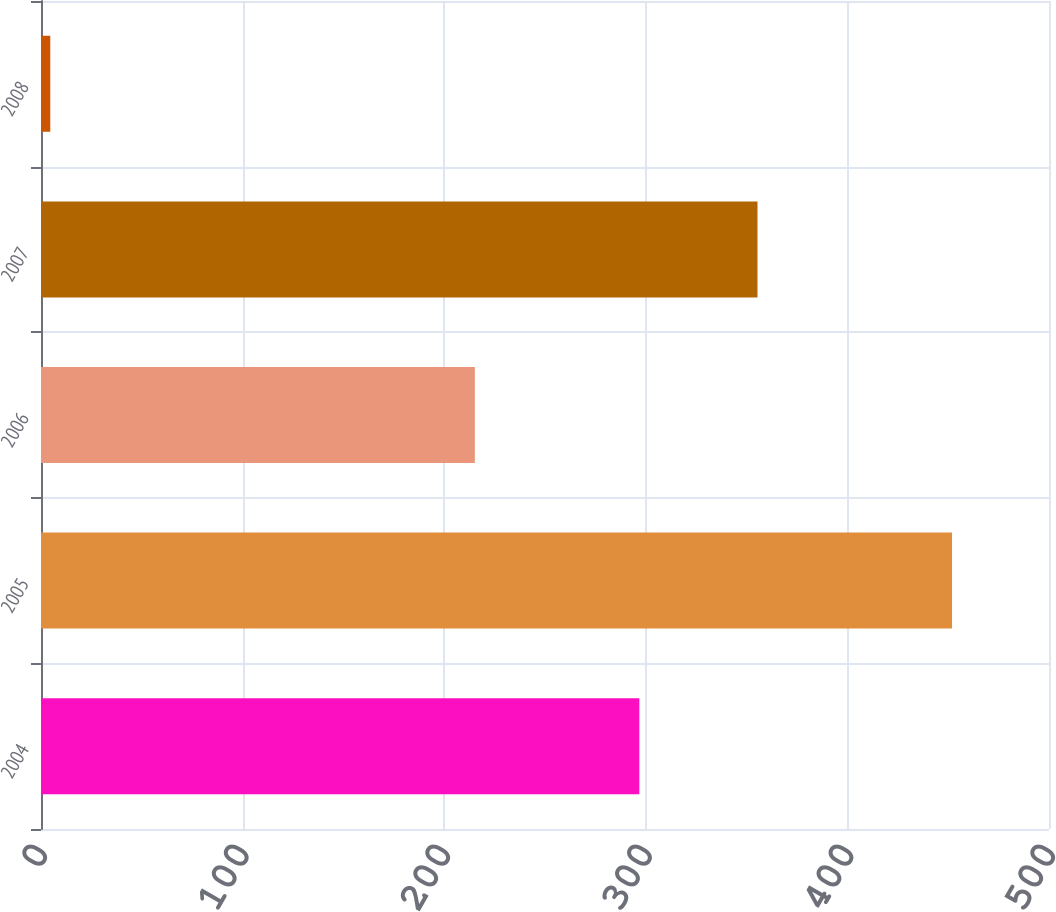Convert chart to OTSL. <chart><loc_0><loc_0><loc_500><loc_500><bar_chart><fcel>2004<fcel>2005<fcel>2006<fcel>2007<fcel>2008<nl><fcel>296.8<fcel>451.9<fcel>215.2<fcel>355.4<fcel>4.6<nl></chart> 